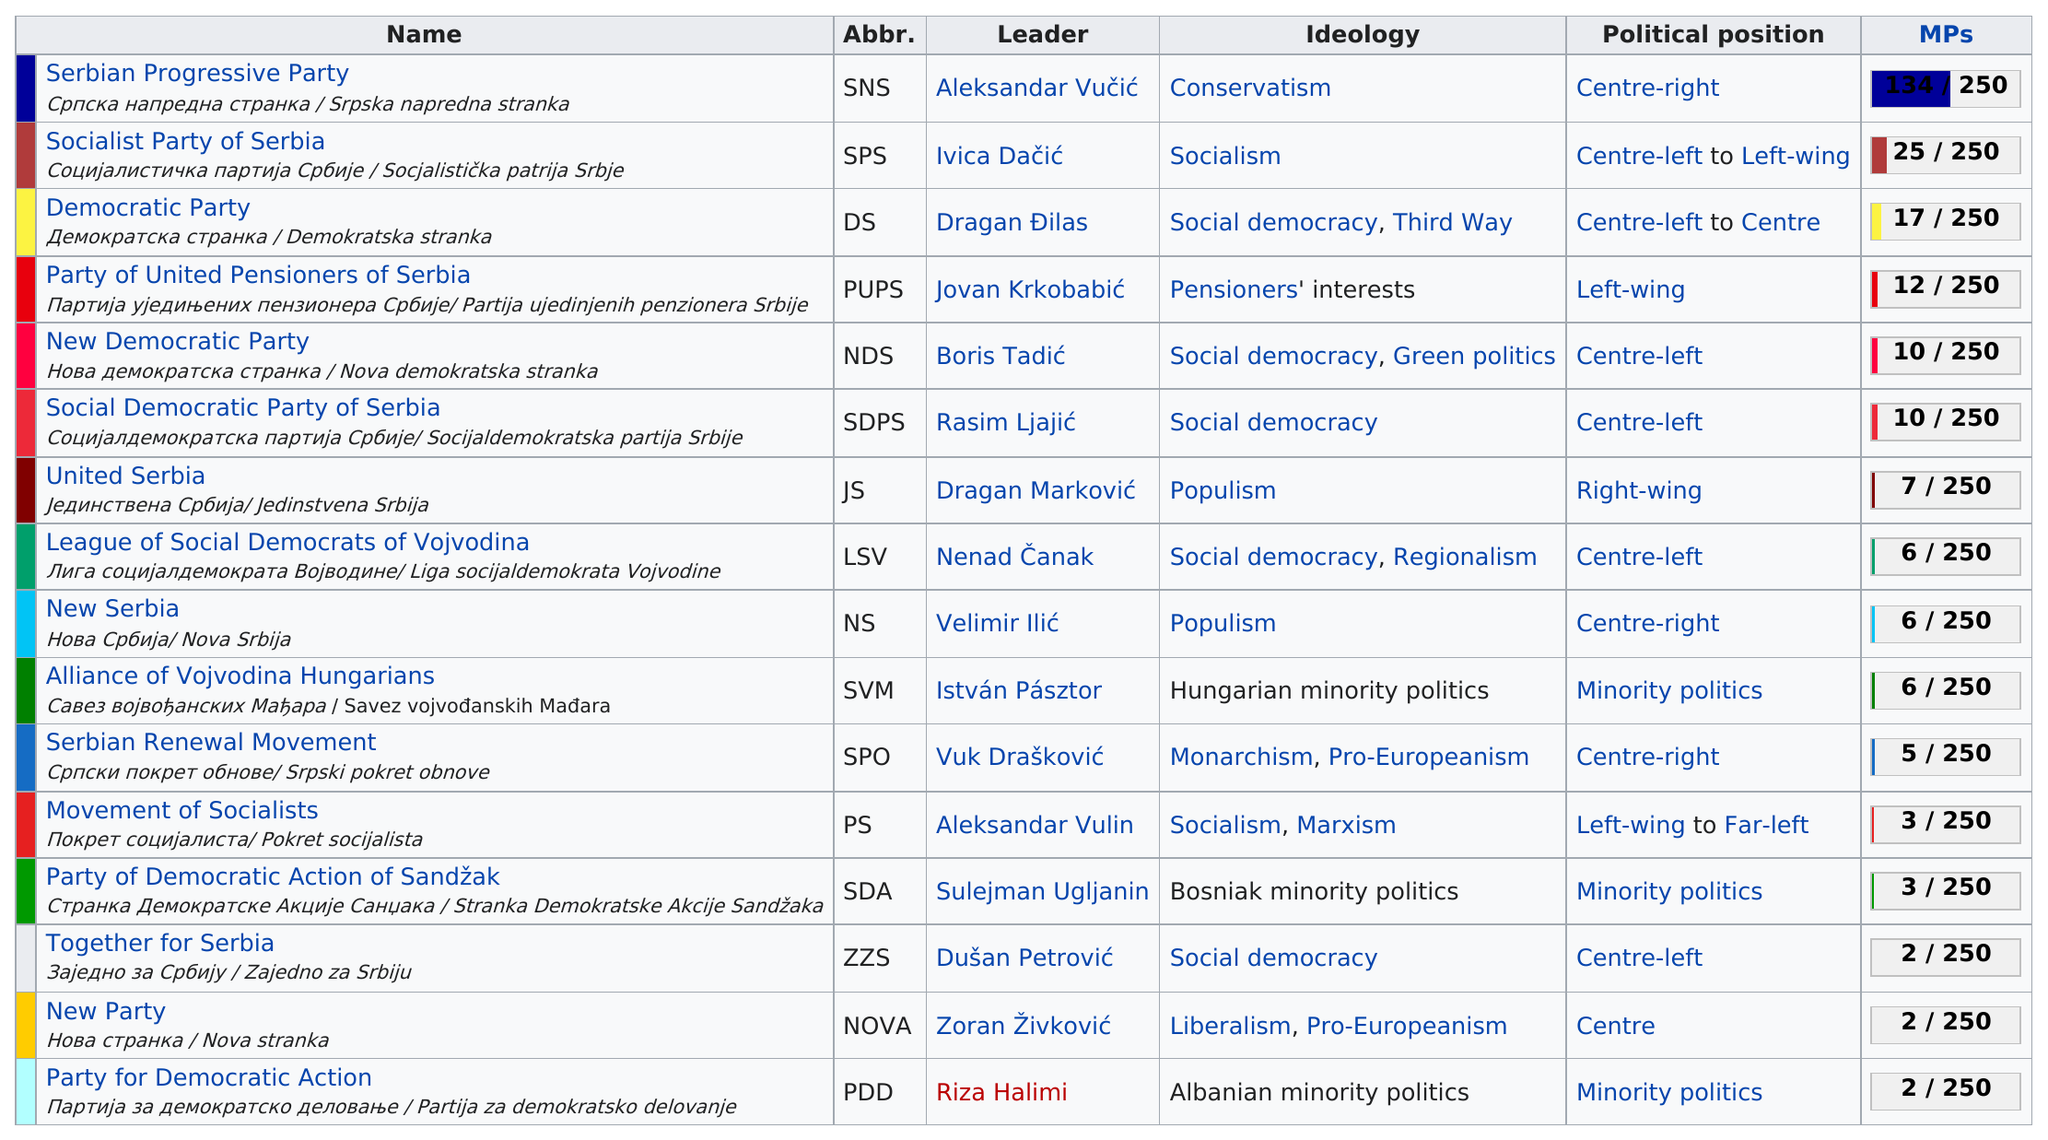Outline some significant characteristics in this image. The total number of groups that have a populism ideology is 2. Nine groups do not follow a socialist ideology. There are approximately 5 parties that follow the ideology of social democracy. The Serbian Progressive Party, also known as the Српска напредна странка / Srpska napredna stranka, currently has the most Members of Parliament (MPs) in Serbia. The total number of mps is 250. 